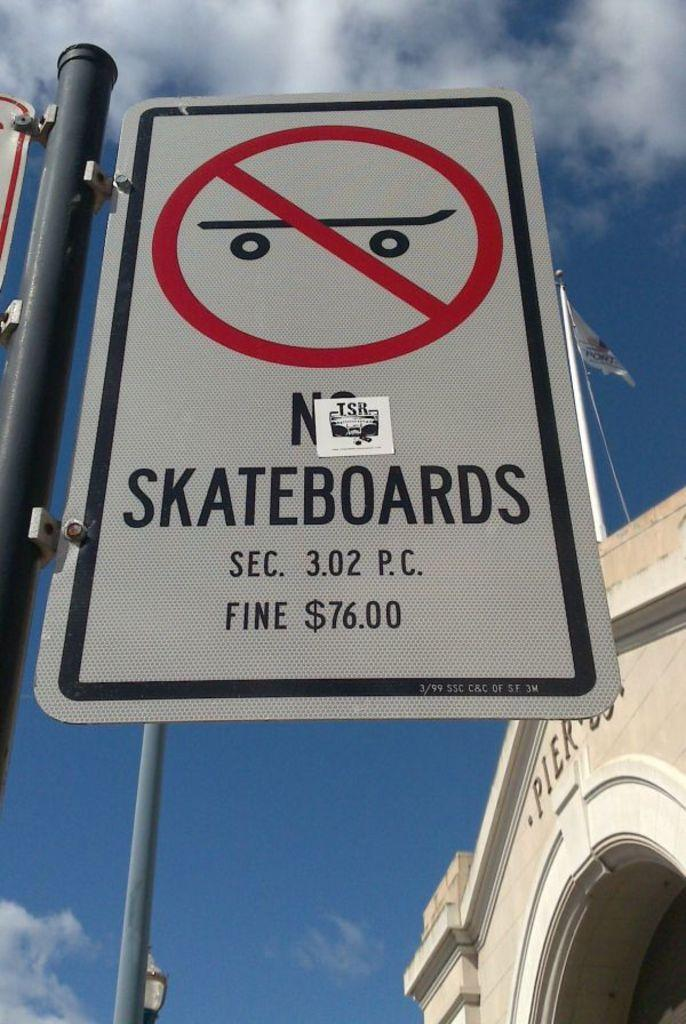<image>
Relay a brief, clear account of the picture shown. White sign on a pole that says "No Skateboards" with a sticker that says TSR. 